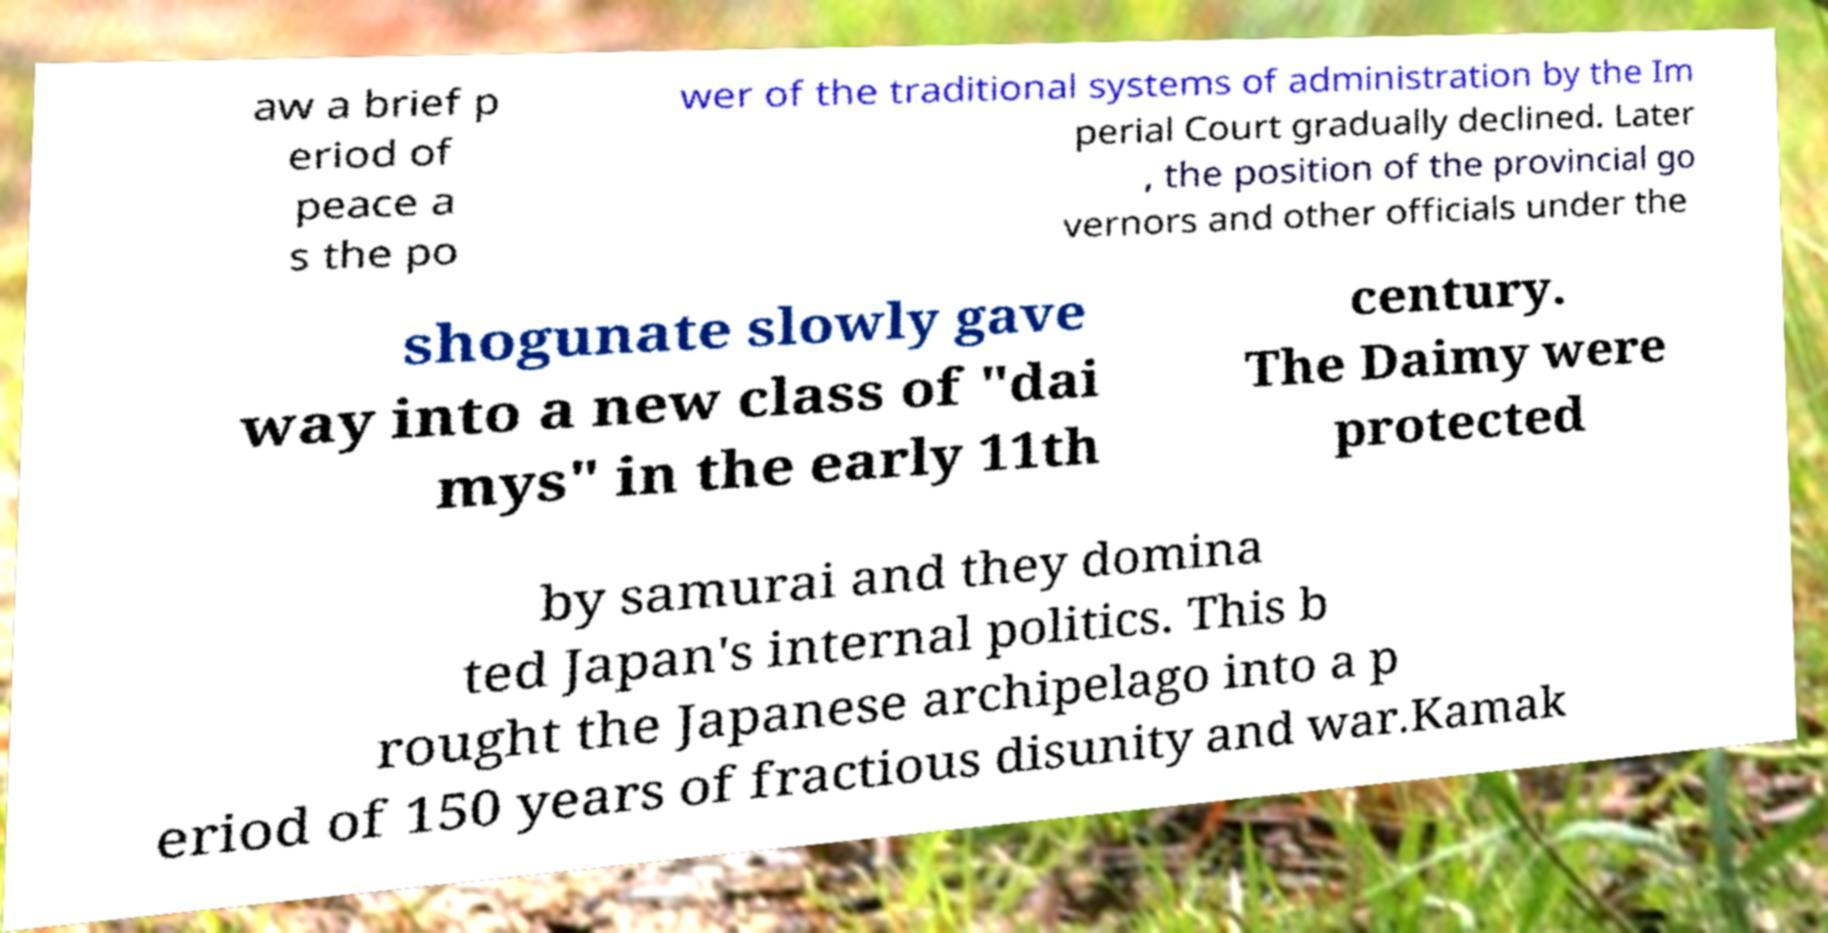What messages or text are displayed in this image? I need them in a readable, typed format. aw a brief p eriod of peace a s the po wer of the traditional systems of administration by the Im perial Court gradually declined. Later , the position of the provincial go vernors and other officials under the shogunate slowly gave way into a new class of "dai mys" in the early 11th century. The Daimy were protected by samurai and they domina ted Japan's internal politics. This b rought the Japanese archipelago into a p eriod of 150 years of fractious disunity and war.Kamak 